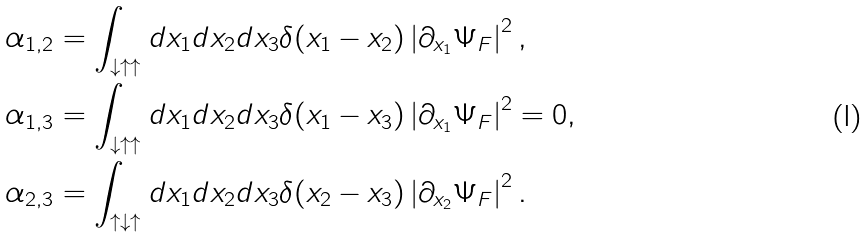<formula> <loc_0><loc_0><loc_500><loc_500>\alpha _ { 1 , 2 } & = \int _ { \downarrow \uparrow \uparrow } d x _ { 1 } d x _ { 2 } d x _ { 3 } \delta ( x _ { 1 } - x _ { 2 } ) \left | \partial _ { x _ { 1 } } \Psi _ { F } \right | ^ { 2 } , \\ \alpha _ { 1 , 3 } & = \int _ { \downarrow \uparrow \uparrow } d x _ { 1 } d x _ { 2 } d x _ { 3 } \delta ( x _ { 1 } - x _ { 3 } ) \left | \partial _ { x _ { 1 } } \Psi _ { F } \right | ^ { 2 } = 0 , \\ \alpha _ { 2 , 3 } & = \int _ { \uparrow \downarrow \uparrow } d x _ { 1 } d x _ { 2 } d x _ { 3 } \delta ( x _ { 2 } - x _ { 3 } ) \left | \partial _ { x _ { 2 } } \Psi _ { F } \right | ^ { 2 } .</formula> 